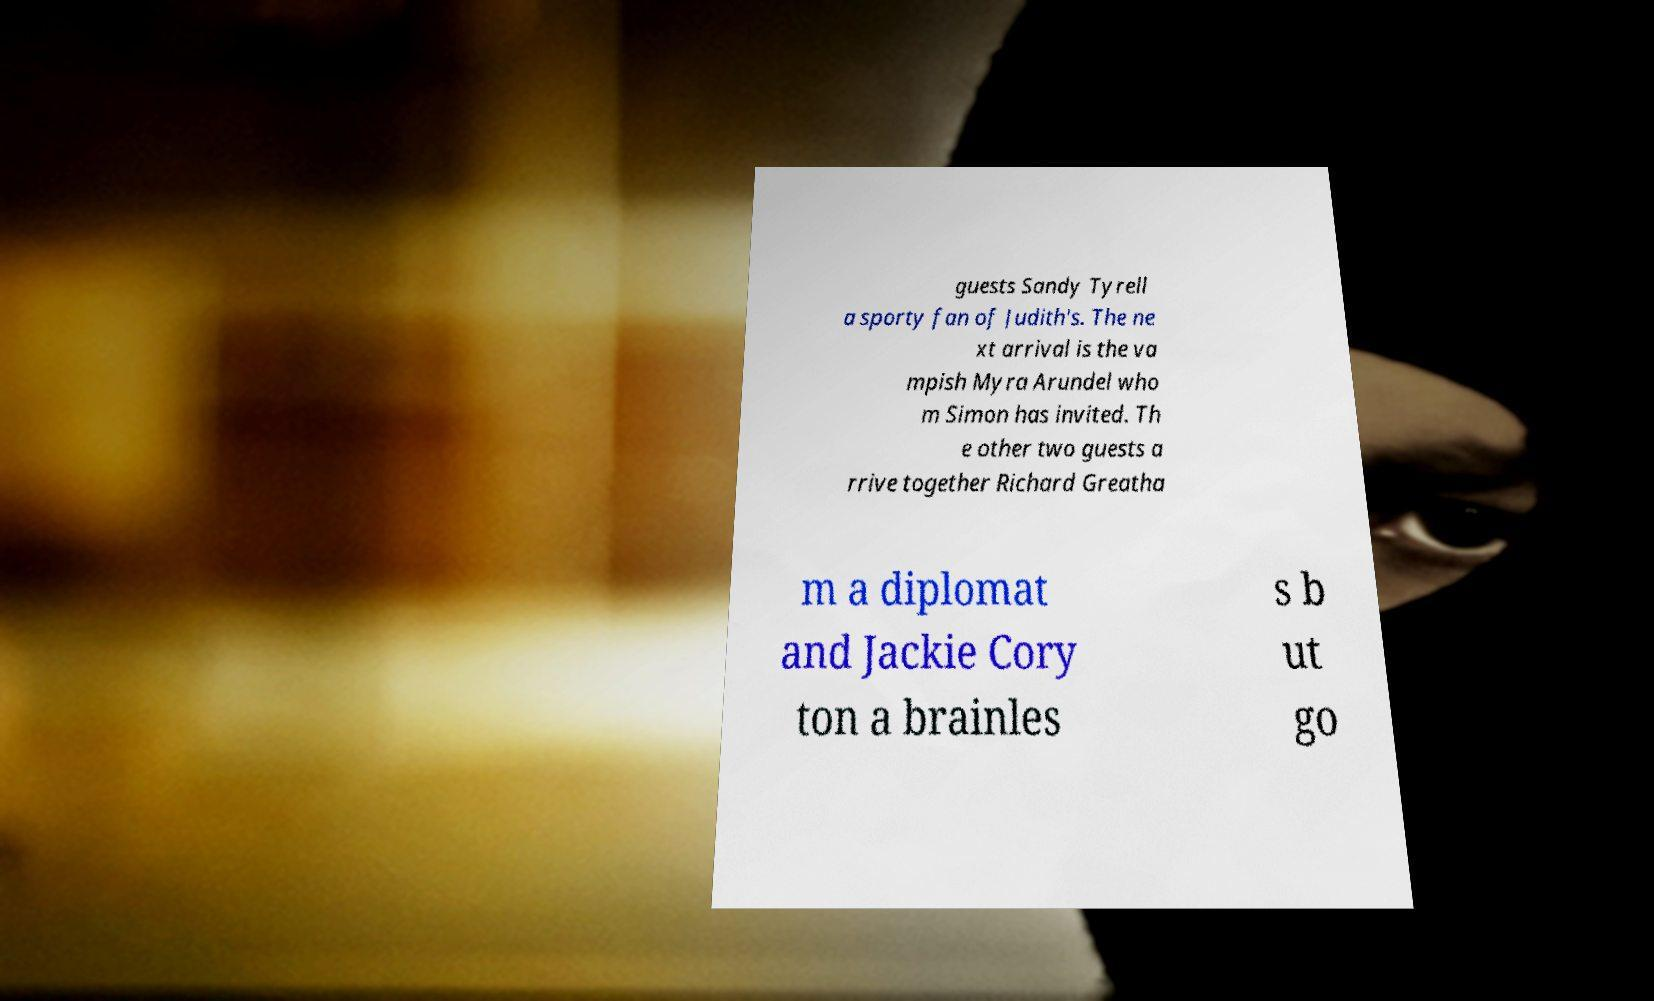Could you assist in decoding the text presented in this image and type it out clearly? guests Sandy Tyrell a sporty fan of Judith's. The ne xt arrival is the va mpish Myra Arundel who m Simon has invited. Th e other two guests a rrive together Richard Greatha m a diplomat and Jackie Cory ton a brainles s b ut go 